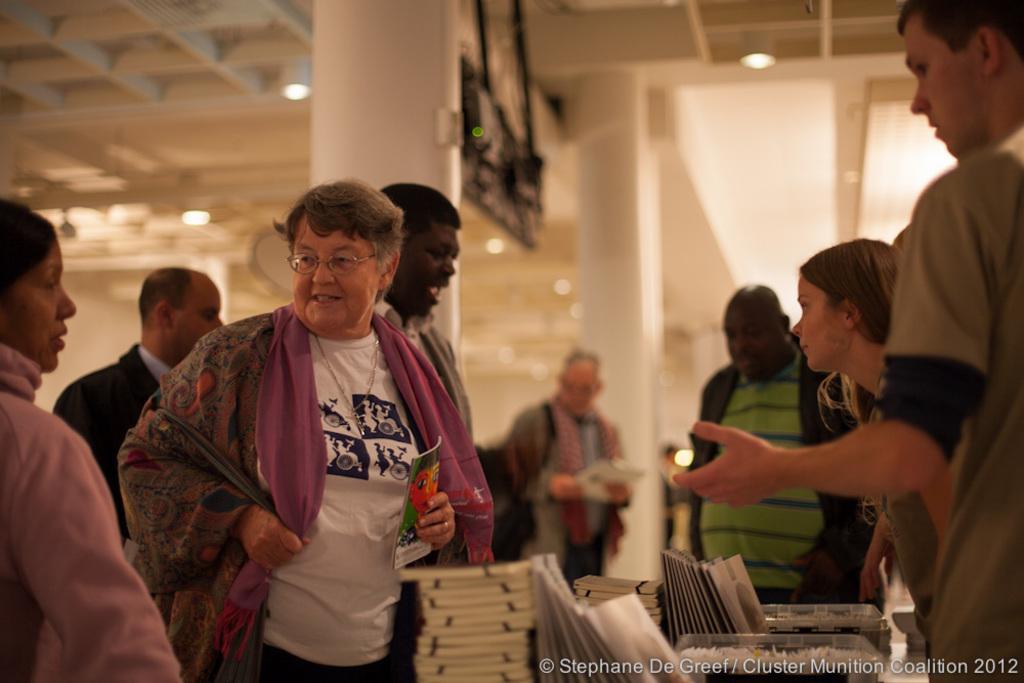How would you summarize this image in a sentence or two? In this image, we can see persons wearing clothes. There are some books and text at the bottom of the image. There are pillars in the middle of the image. There are lights on the ceiling which is at the top of the image. 